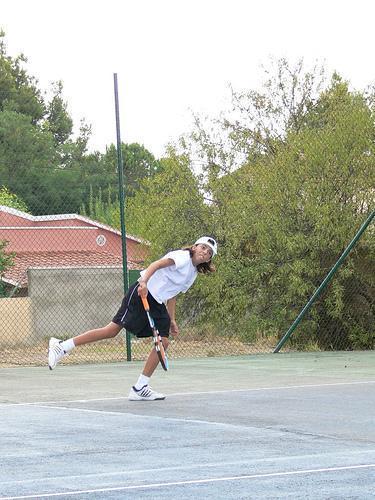How many horses are there?
Give a very brief answer. 0. 